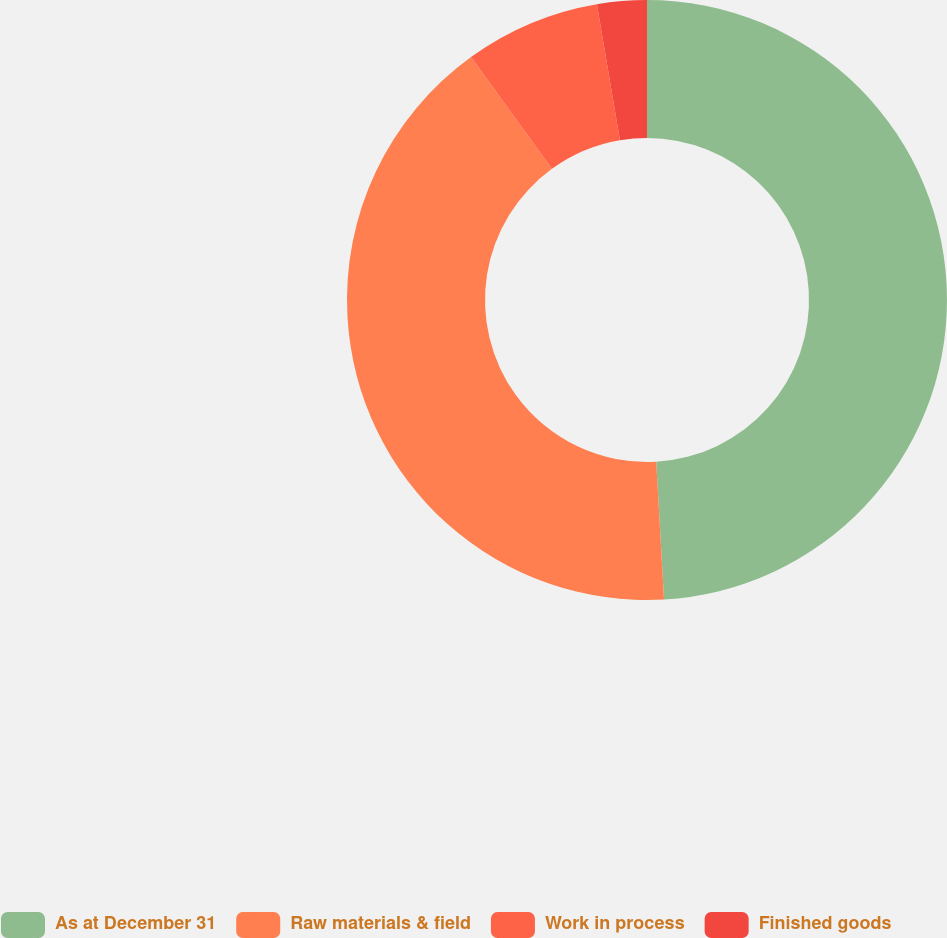Convert chart. <chart><loc_0><loc_0><loc_500><loc_500><pie_chart><fcel>As at December 31<fcel>Raw materials & field<fcel>Work in process<fcel>Finished goods<nl><fcel>49.1%<fcel>40.93%<fcel>7.31%<fcel>2.67%<nl></chart> 